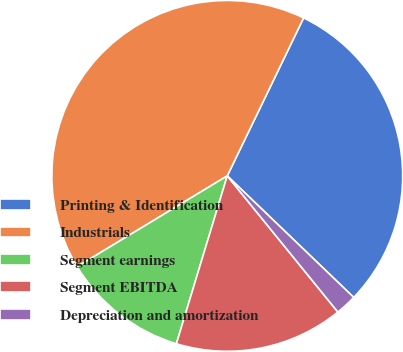Convert chart to OTSL. <chart><loc_0><loc_0><loc_500><loc_500><pie_chart><fcel>Printing & Identification<fcel>Industrials<fcel>Segment earnings<fcel>Segment EBITDA<fcel>Depreciation and amortization<nl><fcel>30.02%<fcel>40.82%<fcel>11.66%<fcel>15.54%<fcel>1.96%<nl></chart> 